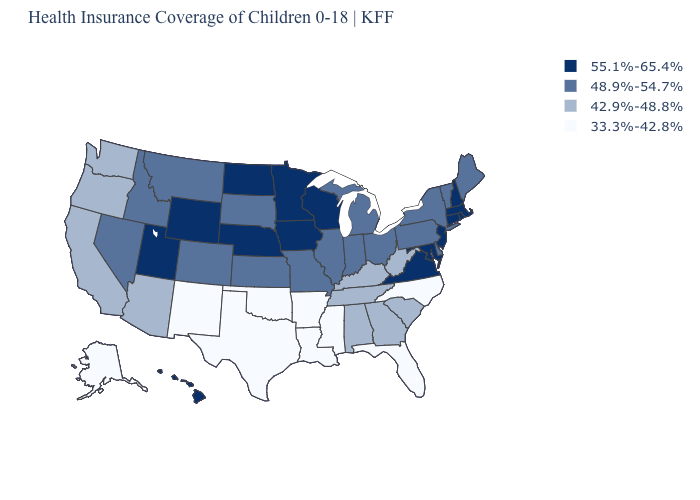Which states hav the highest value in the MidWest?
Be succinct. Iowa, Minnesota, Nebraska, North Dakota, Wisconsin. Among the states that border Michigan , which have the lowest value?
Answer briefly. Indiana, Ohio. What is the value of New York?
Short answer required. 48.9%-54.7%. What is the highest value in the USA?
Short answer required. 55.1%-65.4%. Does the map have missing data?
Give a very brief answer. No. Name the states that have a value in the range 48.9%-54.7%?
Answer briefly. Colorado, Delaware, Idaho, Illinois, Indiana, Kansas, Maine, Michigan, Missouri, Montana, Nevada, New York, Ohio, Pennsylvania, South Dakota, Vermont. Name the states that have a value in the range 33.3%-42.8%?
Short answer required. Alaska, Arkansas, Florida, Louisiana, Mississippi, New Mexico, North Carolina, Oklahoma, Texas. Does the first symbol in the legend represent the smallest category?
Keep it brief. No. What is the value of New York?
Concise answer only. 48.9%-54.7%. Does Connecticut have the same value as Nebraska?
Keep it brief. Yes. Among the states that border Utah , which have the highest value?
Be succinct. Wyoming. Does Nebraska have the same value as Mississippi?
Concise answer only. No. Among the states that border Washington , which have the highest value?
Short answer required. Idaho. What is the value of Maryland?
Give a very brief answer. 55.1%-65.4%. 